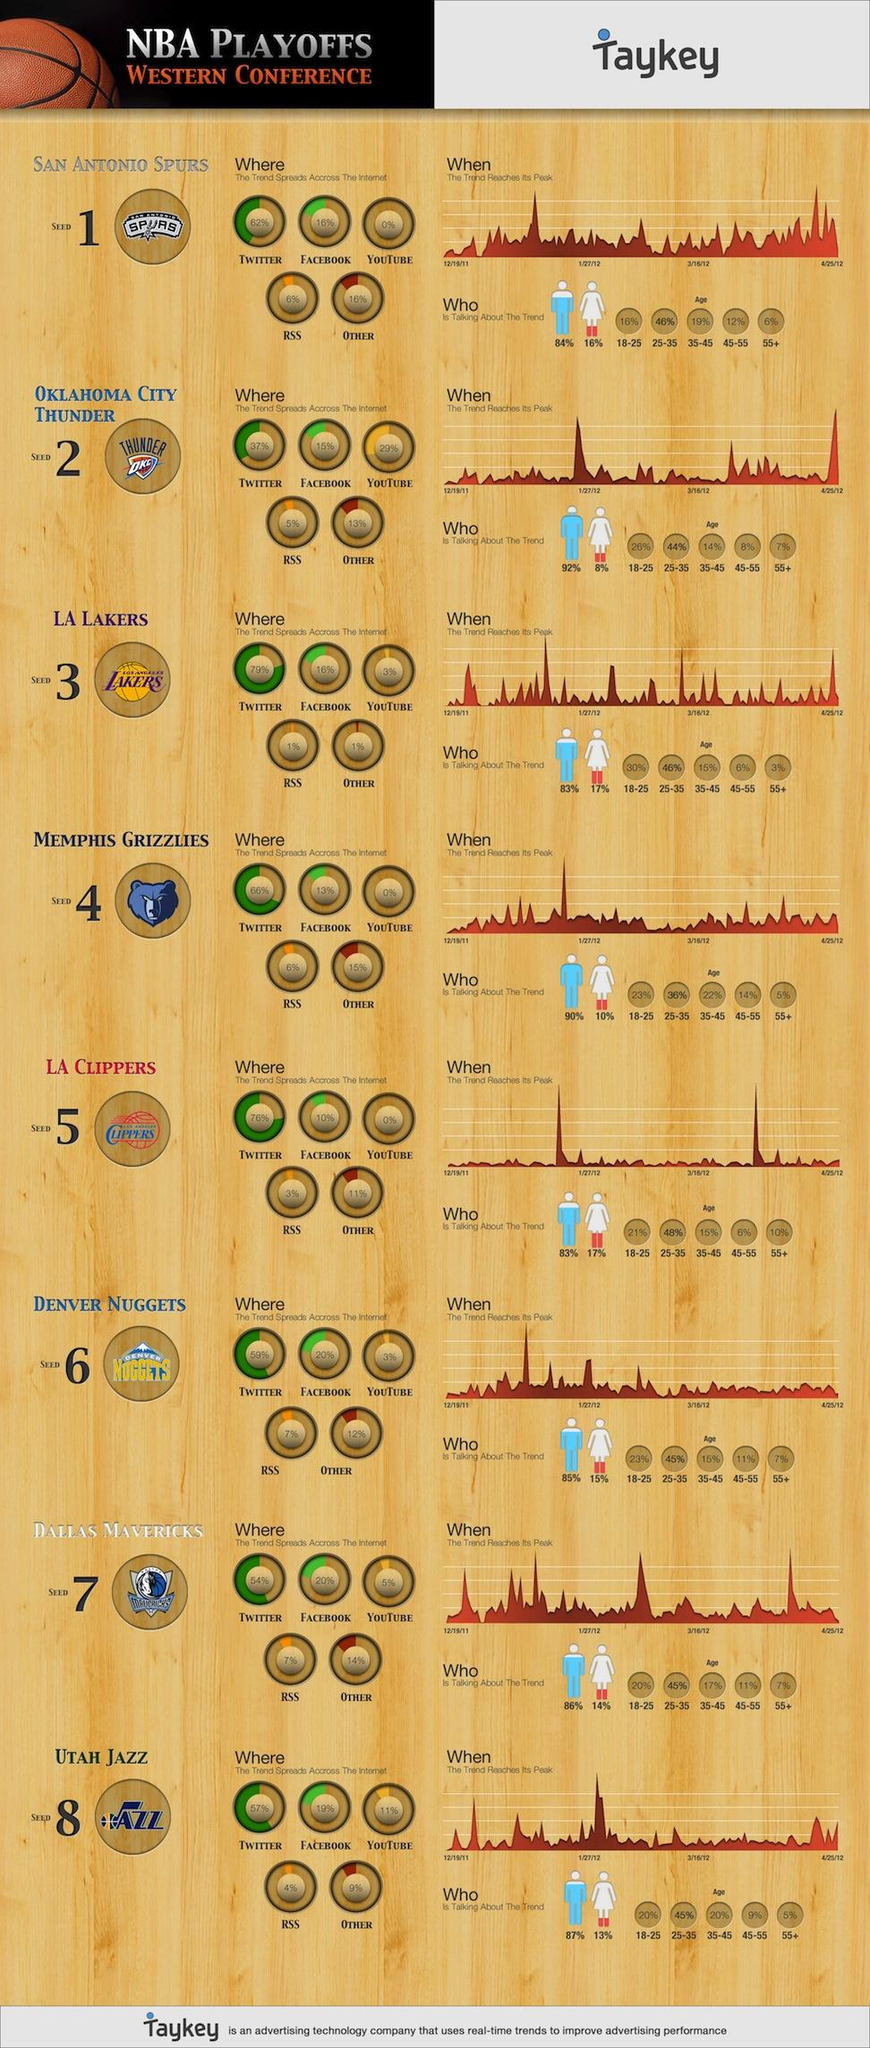Identify some key points in this picture. All" of the basketball teams were trending on Twitter in the social platform. The trend on Twitter for the Memphis Grizzlies is 66%. The Los Angeles Lakers are the most popular basketball team on Twitter, according to recent trends. Six percent of senior citizens are currently discussing the San Antonio Spurs, a professional basketball team based in San Antonio, Texas. A large majority of men, approximately 92%, are discussing the Oklahoma City Thunder. 